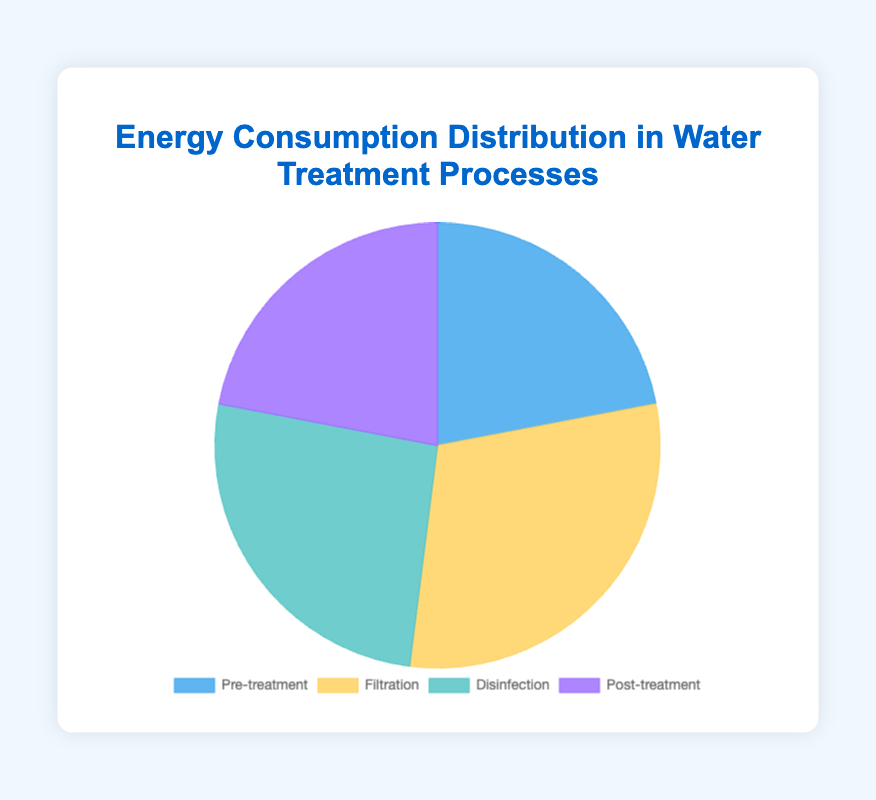what percentage of the total energy consumption is used for Disinfection? The figure shows four sections of the pie chart representing different water treatment processes. To find the percentage for Disinfection, refer to the segment labeled "Disinfection" which is 26%.
Answer: 26% Which treatment process consumes the least energy? To determine the process with the least energy consumption, compare the segments. Both "Pre-treatment" and "Post-treatment" are at 22%, the lowest compared to others.
Answer: Pre-treatment and Post-treatment How much more energy is consumed in Filtration than in Pre-treatment? Filtration uses 30%, and Pre-treatment uses 22%. Subtracting these values (30% - 22%) gives the difference.
Answer: 8% Which treatment processes have equal energy consumption percentages? Look at the pie chart to identify segments with the same percentage values. Both "Pre-treatment" and "Post-treatment" have 22%.
Answer: Pre-treatment and Post-treatment What is the combined energy consumption percentage of all filtration sub-processes? Add the percentages for Microfiltration (8%), Ultrafiltration (12%), and Nanofiltration (10%). Summing these values (8% + 12% + 10%) gives 30%.
Answer: 30% What two processes together account for more than 50% of the energy consumption? Consider pairs of processes supplied by the chart and sum their percentages. Filtration (30%) and Disinfection (26%) together total (30% + 26%) 56%, which is more than 50%.
Answer: Filtration and Disinfection Which segment in the pie chart is represented by the color blue? By visually identifying the colors, the blue segment corresponds to "Pre-treatment".
Answer: Pre-treatment How does the energy consumption of Ozonation compare to that of Reverse Osmosis? From the data, Ozonation consumes 12% while Reverse Osmosis uses 9%. Thus, Ozonation consumes 3% more energy than Reverse Osmosis.
Answer: Ozonation consumes 3% more What is the percentage difference between the highest and the lowest energy-consuming processes? The highest-consuming process is Filtration at 30%, and the lowest are Pre-treatment and Post-treatment at 22%. The difference is calculated as (30% - 22%) 8%.
Answer: 8% What proportion of the total energy is consumed by Coagulation and Ion Exchange combined? Coagulation uses 5% and Ion Exchange uses 8%. Adding these values (5% + 8%) gives 13%.
Answer: 13% 